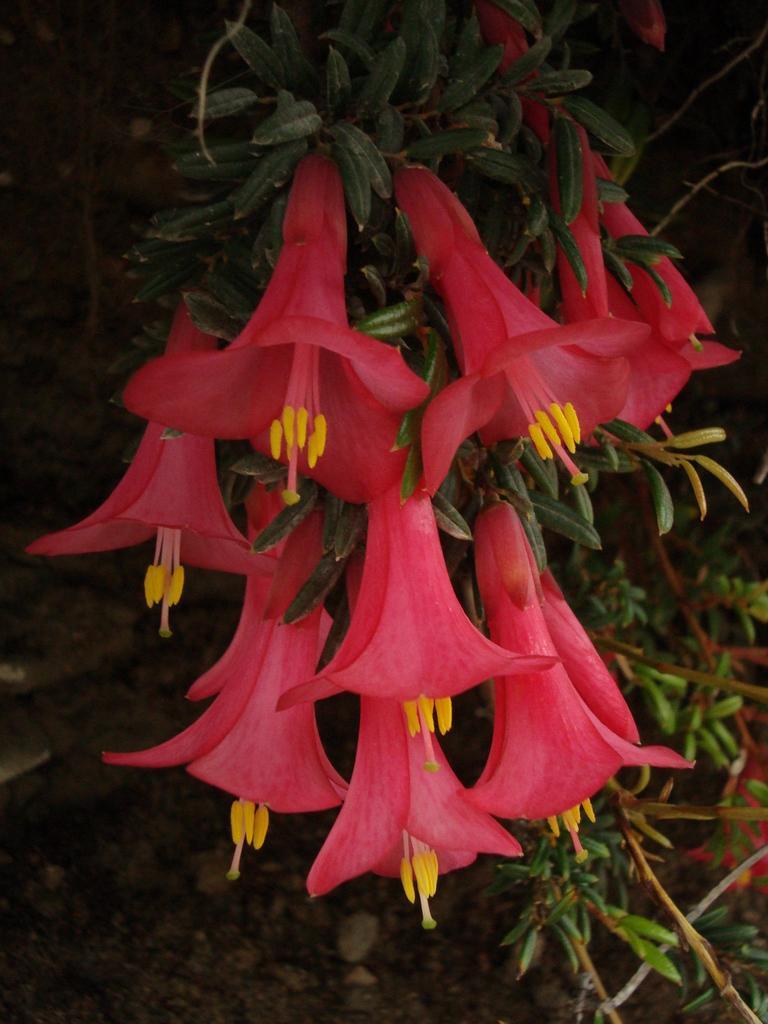Could you give a brief overview of what you see in this image? Here we can see a plant with flowers and in the background the image is not clear. 